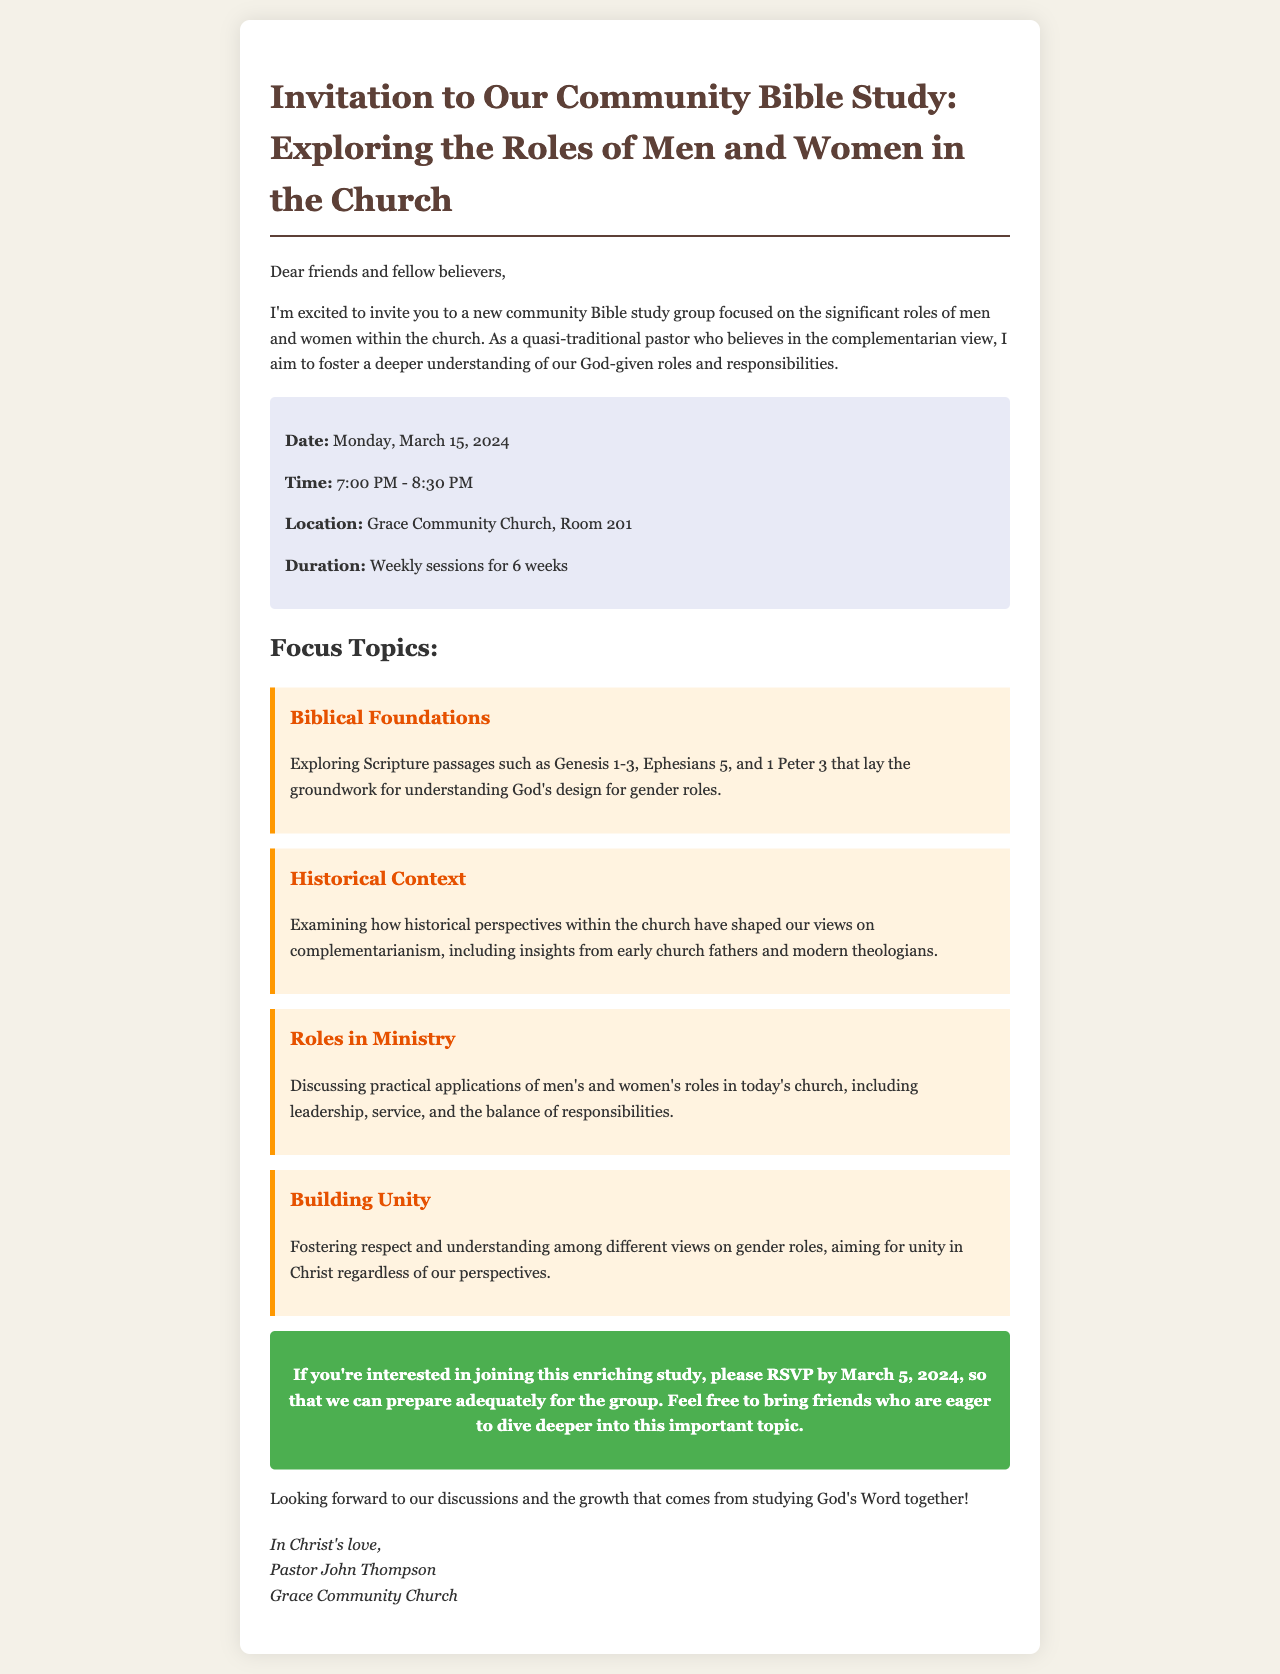What is the date of the Bible study? The date is explicitly stated in the document as Monday, March 15, 2024.
Answer: March 15, 2024 What time does the Bible study start? The start time is listed in the document as 7:00 PM.
Answer: 7:00 PM How long will the Bible study sessions last? The duration is provided as weekly sessions for 6 weeks.
Answer: 6 weeks What is one of the focus topics discussed in the study? The document mentions focus topics including Biblical Foundations, Historical Context, Roles in Ministry, and Building Unity.
Answer: Biblical Foundations Who is the pastor leading the Bible study? The document identifies Pastor John Thompson as the leader of the study group.
Answer: Pastor John Thompson What is the main goal of the Bible study group? The document states the aim is to foster a deeper understanding of God-given roles and responsibilities.
Answer: Deeper understanding of roles When is the RSVP deadline? The RSVP deadline is mentioned as March 5, 2024.
Answer: March 5, 2024 Where will the Bible study take place? The location specified in the document is Grace Community Church, Room 201.
Answer: Grace Community Church, Room 201 What type of church perspective does the pastor hold? The email indicates that the pastor holds a complementarian view regarding gender roles.
Answer: Complementarian view 